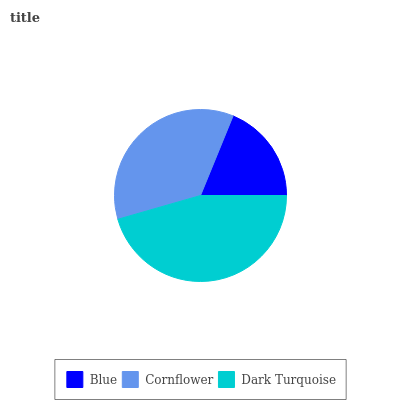Is Blue the minimum?
Answer yes or no. Yes. Is Dark Turquoise the maximum?
Answer yes or no. Yes. Is Cornflower the minimum?
Answer yes or no. No. Is Cornflower the maximum?
Answer yes or no. No. Is Cornflower greater than Blue?
Answer yes or no. Yes. Is Blue less than Cornflower?
Answer yes or no. Yes. Is Blue greater than Cornflower?
Answer yes or no. No. Is Cornflower less than Blue?
Answer yes or no. No. Is Cornflower the high median?
Answer yes or no. Yes. Is Cornflower the low median?
Answer yes or no. Yes. Is Blue the high median?
Answer yes or no. No. Is Blue the low median?
Answer yes or no. No. 